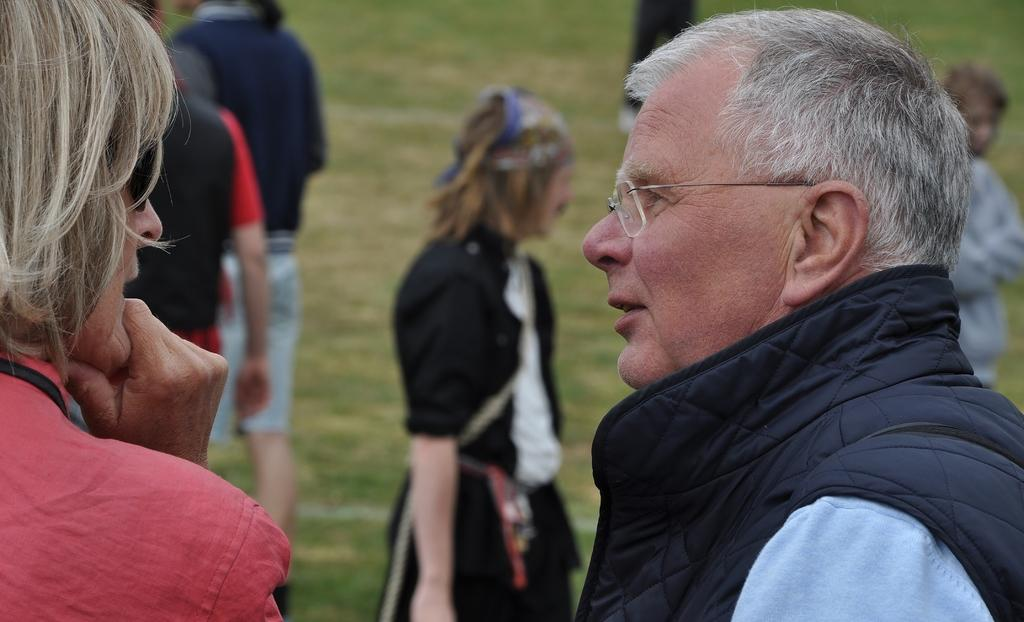How many people are in the image? There are persons in the image, but the exact number is not specified. What is the position of the persons in the image? The persons are on the ground in the image. What type of surface are the persons on? There is grass in the image, so the surface is grass. What type of square can be seen in the image? There is no square present in the image. What type of game are the persons playing in the image? The facts provided do not mention any game or activity being played by the persons in the image. 